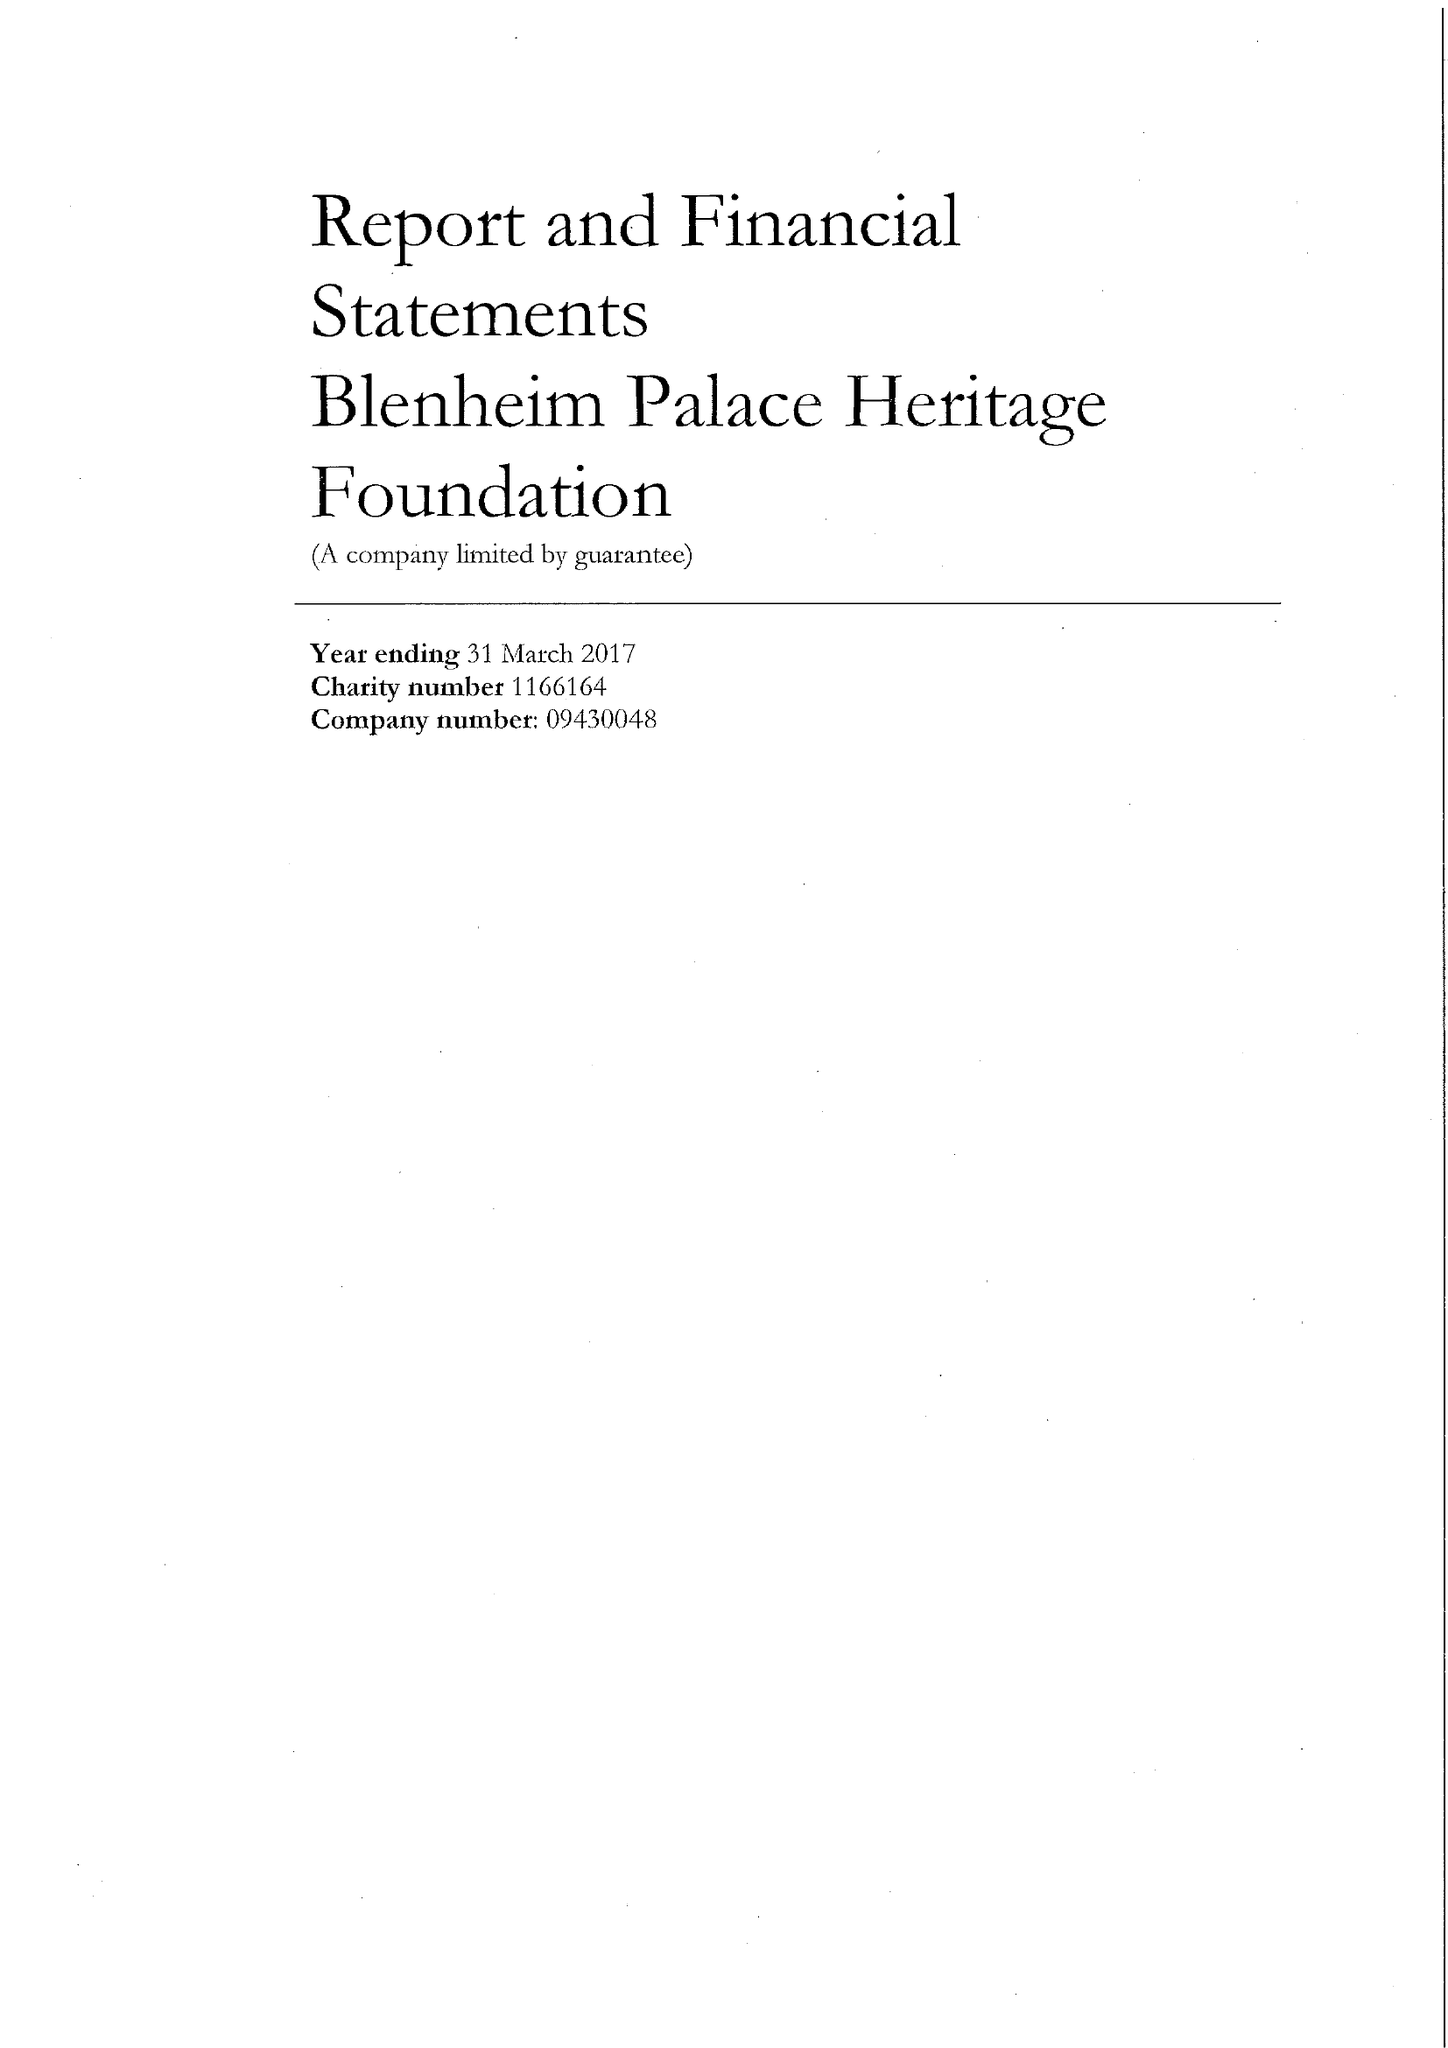What is the value for the charity_name?
Answer the question using a single word or phrase. Blenheim Palace Heritage Foundation 